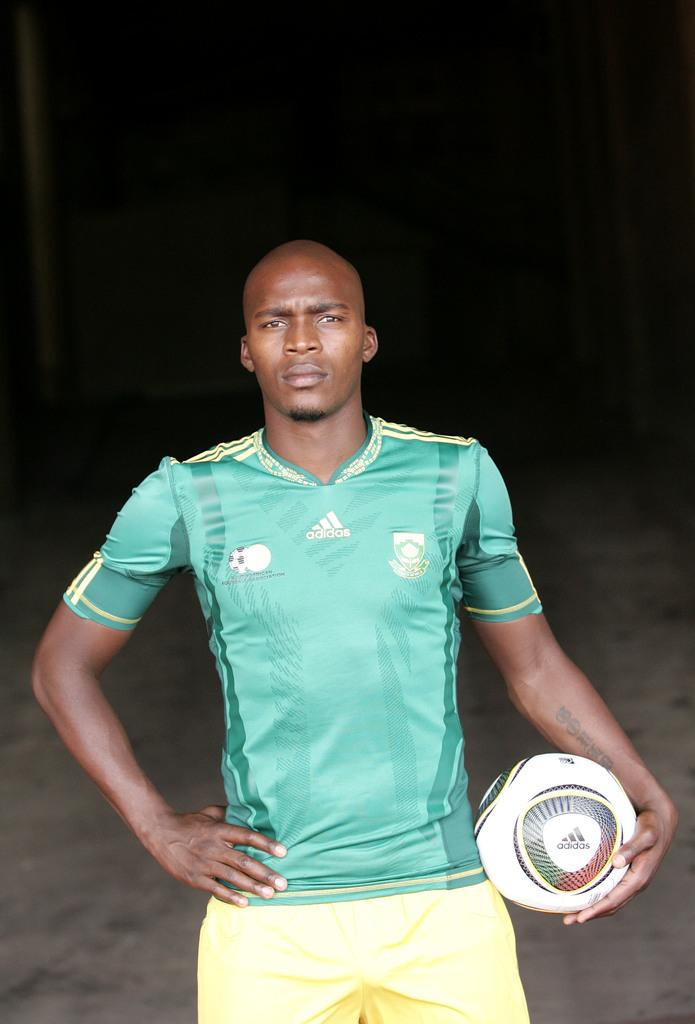What is the main subject of the image? There is a man in the image. What is the man wearing? The man is wearing a football jersey. What is the man holding in the image? The man is holding a football. What type of party is the man attending in the image? There is no indication of a party in the image; it only shows a man wearing a football jersey and holding a football. 